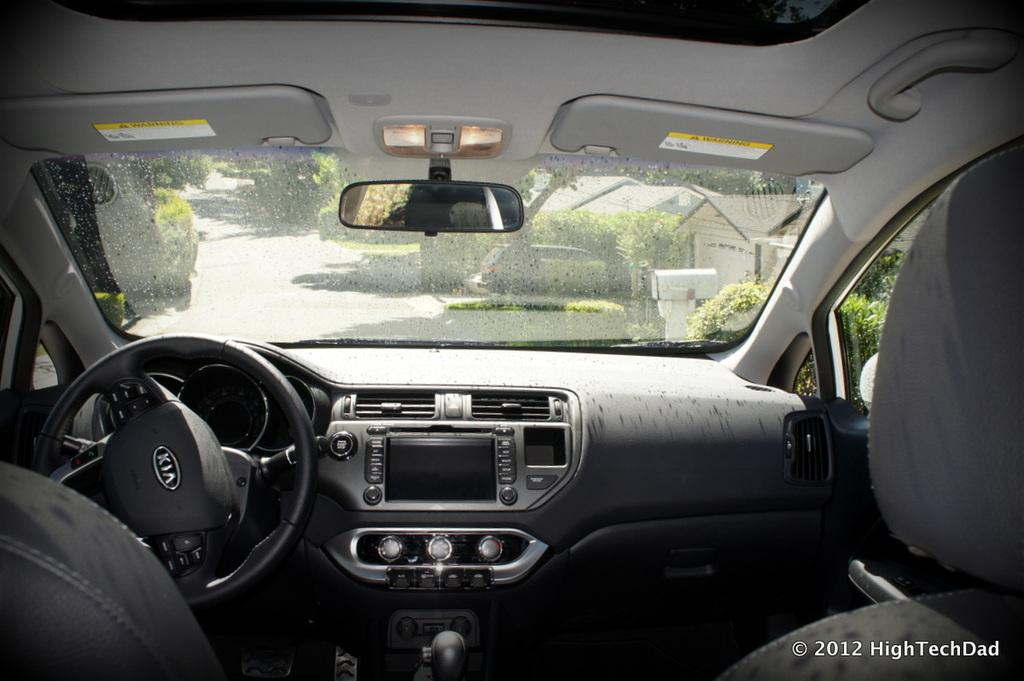What type of location is depicted in the image? The image is an inside view of a vehicle. What is a key component of the vehicle's interior? There is a steering wheel in the image. What is provided for passengers in the vehicle? There are seats in the image. What is used for visibility while driving? There is a mirror in the image. What can be seen outside the vehicle through the glass? Plants, trees, houses, and a road are visible through the glass. What type of popcorn is being eaten by the driver in the image? There is no popcorn present in the image; it is an inside view of a vehicle with a focus on the vehicle's interior and the surrounding environment. 